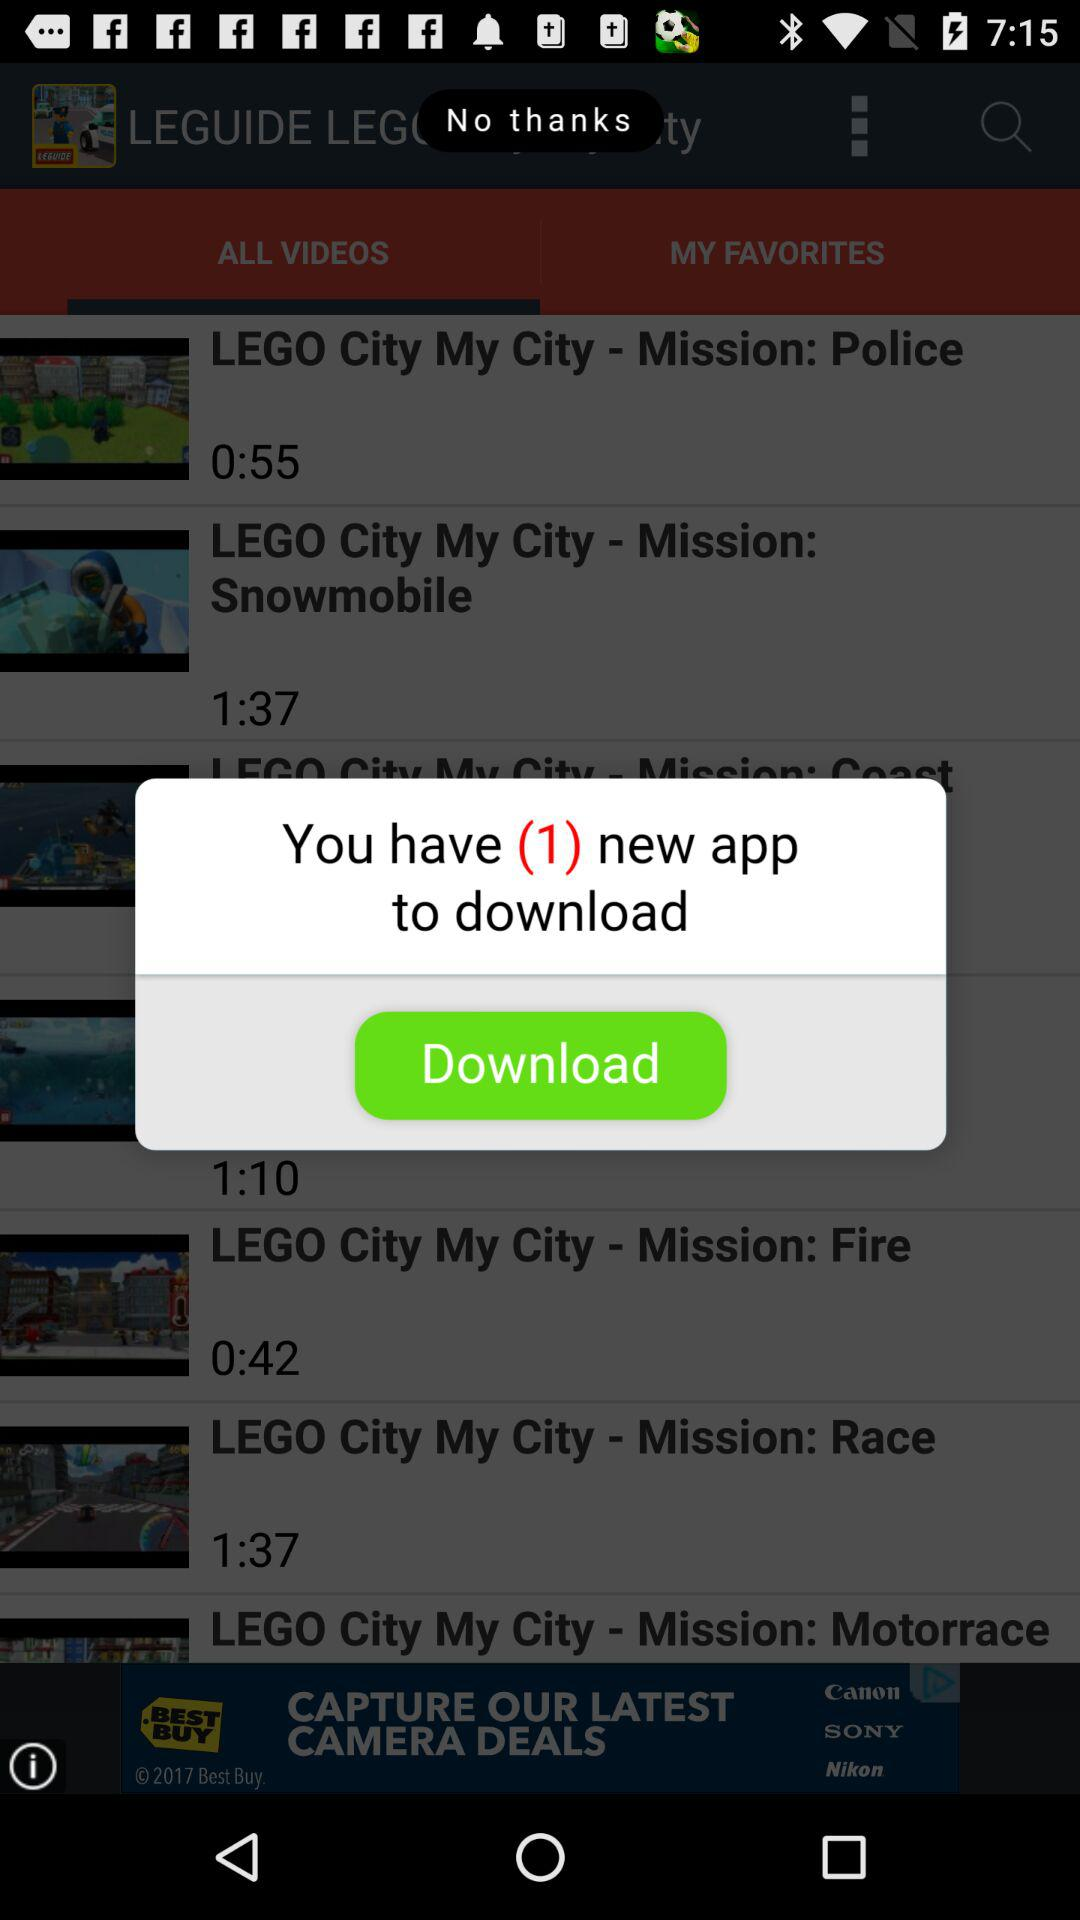What is the duration of the video "LEGO City My City - Mission: Police"? The duration is 55 seconds. 